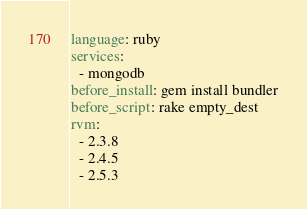Convert code to text. <code><loc_0><loc_0><loc_500><loc_500><_YAML_>language: ruby
services:
  - mongodb
before_install: gem install bundler
before_script: rake empty_dest
rvm:
  - 2.3.8
  - 2.4.5
  - 2.5.3
</code> 